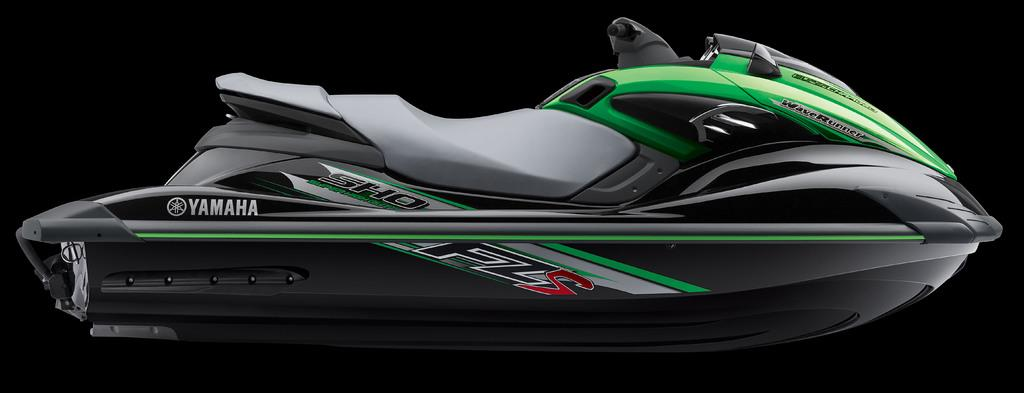What is the main subject of the image? The main subject of the image is a jet ski. What emotion is the jet ski expressing in the image? Jet skis do not have emotions, as they are inanimate objects. 